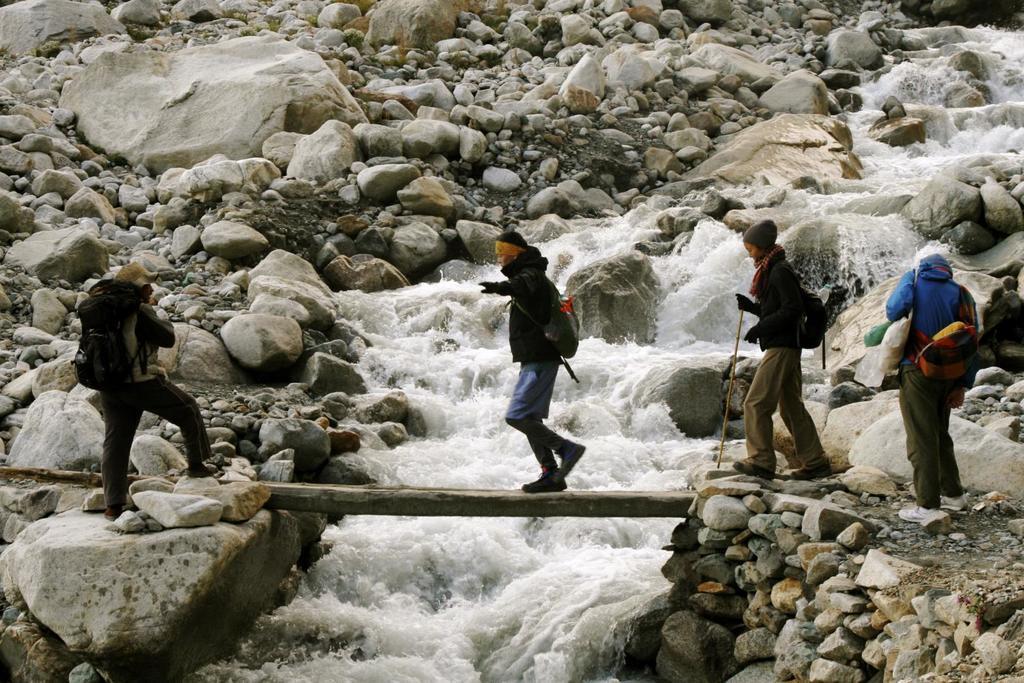How would you summarize this image in a sentence or two? In this image we can see four persons standing on the ground. One person wearing headband, jacket and a bag is standing on a wood log. In the background we can see water and group of stones. 